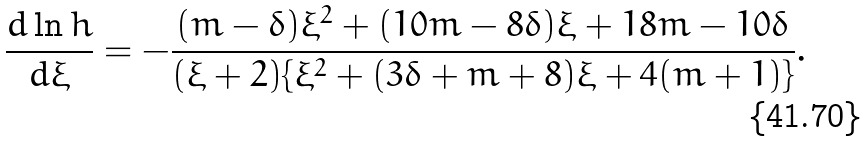<formula> <loc_0><loc_0><loc_500><loc_500>\frac { d \ln h } { d \xi } = - \frac { ( m - \delta ) \xi ^ { 2 } + ( 1 0 m - 8 \delta ) \xi + 1 8 m - 1 0 \delta } { ( \xi + 2 ) \{ \xi ^ { 2 } + ( 3 \delta + m + 8 ) \xi + 4 ( m + 1 ) \} } .</formula> 